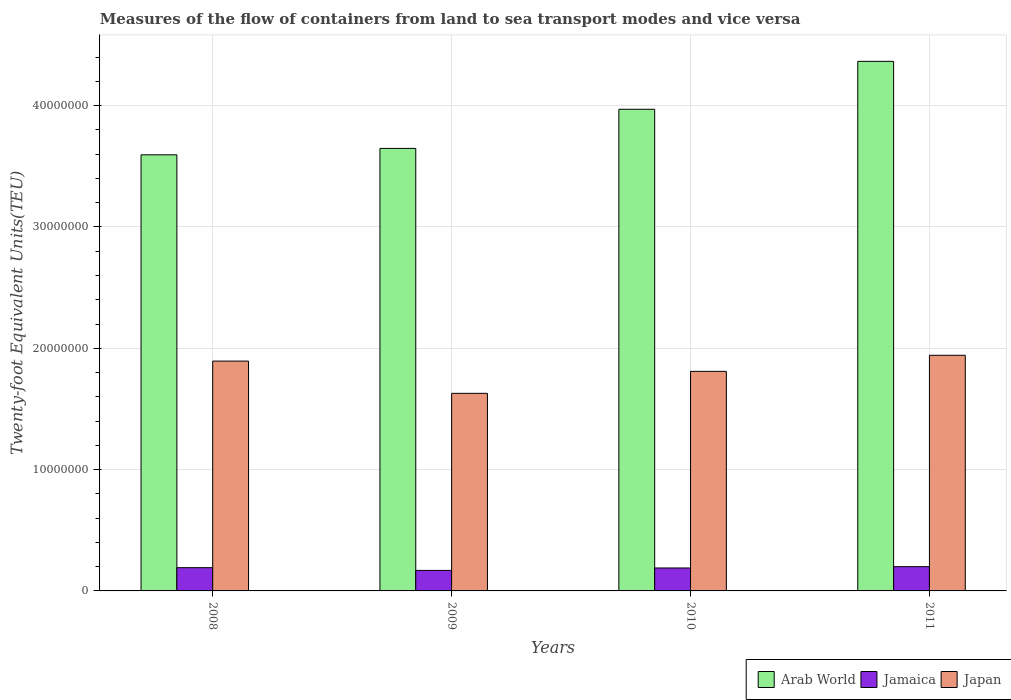How many different coloured bars are there?
Your answer should be compact. 3. How many groups of bars are there?
Ensure brevity in your answer.  4. Are the number of bars per tick equal to the number of legend labels?
Give a very brief answer. Yes. Are the number of bars on each tick of the X-axis equal?
Make the answer very short. Yes. How many bars are there on the 1st tick from the left?
Your answer should be compact. 3. How many bars are there on the 3rd tick from the right?
Ensure brevity in your answer.  3. What is the label of the 1st group of bars from the left?
Ensure brevity in your answer.  2008. What is the container port traffic in Jamaica in 2008?
Ensure brevity in your answer.  1.92e+06. Across all years, what is the maximum container port traffic in Japan?
Keep it short and to the point. 1.94e+07. Across all years, what is the minimum container port traffic in Japan?
Provide a short and direct response. 1.63e+07. In which year was the container port traffic in Japan minimum?
Your answer should be very brief. 2009. What is the total container port traffic in Jamaica in the graph?
Provide a short and direct response. 7.50e+06. What is the difference between the container port traffic in Japan in 2009 and that in 2010?
Keep it short and to the point. -1.81e+06. What is the difference between the container port traffic in Jamaica in 2008 and the container port traffic in Arab World in 2010?
Provide a short and direct response. -3.78e+07. What is the average container port traffic in Arab World per year?
Offer a terse response. 3.89e+07. In the year 2008, what is the difference between the container port traffic in Arab World and container port traffic in Japan?
Provide a succinct answer. 1.70e+07. What is the ratio of the container port traffic in Jamaica in 2008 to that in 2009?
Give a very brief answer. 1.13. Is the difference between the container port traffic in Arab World in 2009 and 2011 greater than the difference between the container port traffic in Japan in 2009 and 2011?
Offer a very short reply. No. What is the difference between the highest and the second highest container port traffic in Japan?
Give a very brief answer. 4.79e+05. What is the difference between the highest and the lowest container port traffic in Arab World?
Your response must be concise. 7.70e+06. Is the sum of the container port traffic in Japan in 2009 and 2011 greater than the maximum container port traffic in Jamaica across all years?
Give a very brief answer. Yes. What does the 2nd bar from the right in 2008 represents?
Provide a succinct answer. Jamaica. Is it the case that in every year, the sum of the container port traffic in Jamaica and container port traffic in Arab World is greater than the container port traffic in Japan?
Provide a short and direct response. Yes. How many bars are there?
Provide a short and direct response. 12. Are all the bars in the graph horizontal?
Give a very brief answer. No. What is the difference between two consecutive major ticks on the Y-axis?
Offer a very short reply. 1.00e+07. Are the values on the major ticks of Y-axis written in scientific E-notation?
Provide a short and direct response. No. Does the graph contain grids?
Keep it short and to the point. Yes. How many legend labels are there?
Provide a short and direct response. 3. What is the title of the graph?
Offer a terse response. Measures of the flow of containers from land to sea transport modes and vice versa. What is the label or title of the X-axis?
Offer a terse response. Years. What is the label or title of the Y-axis?
Provide a succinct answer. Twenty-foot Equivalent Units(TEU). What is the Twenty-foot Equivalent Units(TEU) of Arab World in 2008?
Your answer should be very brief. 3.59e+07. What is the Twenty-foot Equivalent Units(TEU) in Jamaica in 2008?
Your answer should be very brief. 1.92e+06. What is the Twenty-foot Equivalent Units(TEU) of Japan in 2008?
Keep it short and to the point. 1.89e+07. What is the Twenty-foot Equivalent Units(TEU) of Arab World in 2009?
Keep it short and to the point. 3.65e+07. What is the Twenty-foot Equivalent Units(TEU) in Jamaica in 2009?
Provide a succinct answer. 1.69e+06. What is the Twenty-foot Equivalent Units(TEU) of Japan in 2009?
Make the answer very short. 1.63e+07. What is the Twenty-foot Equivalent Units(TEU) in Arab World in 2010?
Your answer should be very brief. 3.97e+07. What is the Twenty-foot Equivalent Units(TEU) of Jamaica in 2010?
Make the answer very short. 1.89e+06. What is the Twenty-foot Equivalent Units(TEU) of Japan in 2010?
Give a very brief answer. 1.81e+07. What is the Twenty-foot Equivalent Units(TEU) of Arab World in 2011?
Your response must be concise. 4.36e+07. What is the Twenty-foot Equivalent Units(TEU) of Jamaica in 2011?
Provide a succinct answer. 2.00e+06. What is the Twenty-foot Equivalent Units(TEU) of Japan in 2011?
Provide a short and direct response. 1.94e+07. Across all years, what is the maximum Twenty-foot Equivalent Units(TEU) of Arab World?
Ensure brevity in your answer.  4.36e+07. Across all years, what is the maximum Twenty-foot Equivalent Units(TEU) in Jamaica?
Ensure brevity in your answer.  2.00e+06. Across all years, what is the maximum Twenty-foot Equivalent Units(TEU) of Japan?
Make the answer very short. 1.94e+07. Across all years, what is the minimum Twenty-foot Equivalent Units(TEU) of Arab World?
Offer a terse response. 3.59e+07. Across all years, what is the minimum Twenty-foot Equivalent Units(TEU) in Jamaica?
Offer a very short reply. 1.69e+06. Across all years, what is the minimum Twenty-foot Equivalent Units(TEU) in Japan?
Provide a succinct answer. 1.63e+07. What is the total Twenty-foot Equivalent Units(TEU) in Arab World in the graph?
Your response must be concise. 1.56e+08. What is the total Twenty-foot Equivalent Units(TEU) of Jamaica in the graph?
Provide a succinct answer. 7.50e+06. What is the total Twenty-foot Equivalent Units(TEU) in Japan in the graph?
Offer a very short reply. 7.28e+07. What is the difference between the Twenty-foot Equivalent Units(TEU) of Arab World in 2008 and that in 2009?
Your answer should be compact. -5.29e+05. What is the difference between the Twenty-foot Equivalent Units(TEU) of Jamaica in 2008 and that in 2009?
Provide a succinct answer. 2.26e+05. What is the difference between the Twenty-foot Equivalent Units(TEU) of Japan in 2008 and that in 2009?
Offer a terse response. 2.66e+06. What is the difference between the Twenty-foot Equivalent Units(TEU) in Arab World in 2008 and that in 2010?
Provide a succinct answer. -3.75e+06. What is the difference between the Twenty-foot Equivalent Units(TEU) of Jamaica in 2008 and that in 2010?
Your answer should be very brief. 2.42e+04. What is the difference between the Twenty-foot Equivalent Units(TEU) of Japan in 2008 and that in 2010?
Ensure brevity in your answer.  8.45e+05. What is the difference between the Twenty-foot Equivalent Units(TEU) of Arab World in 2008 and that in 2011?
Ensure brevity in your answer.  -7.70e+06. What is the difference between the Twenty-foot Equivalent Units(TEU) of Jamaica in 2008 and that in 2011?
Your answer should be compact. -8.37e+04. What is the difference between the Twenty-foot Equivalent Units(TEU) of Japan in 2008 and that in 2011?
Offer a very short reply. -4.79e+05. What is the difference between the Twenty-foot Equivalent Units(TEU) in Arab World in 2009 and that in 2010?
Offer a terse response. -3.22e+06. What is the difference between the Twenty-foot Equivalent Units(TEU) of Jamaica in 2009 and that in 2010?
Your answer should be very brief. -2.02e+05. What is the difference between the Twenty-foot Equivalent Units(TEU) in Japan in 2009 and that in 2010?
Make the answer very short. -1.81e+06. What is the difference between the Twenty-foot Equivalent Units(TEU) of Arab World in 2009 and that in 2011?
Provide a succinct answer. -7.17e+06. What is the difference between the Twenty-foot Equivalent Units(TEU) of Jamaica in 2009 and that in 2011?
Provide a short and direct response. -3.10e+05. What is the difference between the Twenty-foot Equivalent Units(TEU) in Japan in 2009 and that in 2011?
Offer a terse response. -3.14e+06. What is the difference between the Twenty-foot Equivalent Units(TEU) in Arab World in 2010 and that in 2011?
Your answer should be compact. -3.95e+06. What is the difference between the Twenty-foot Equivalent Units(TEU) in Jamaica in 2010 and that in 2011?
Keep it short and to the point. -1.08e+05. What is the difference between the Twenty-foot Equivalent Units(TEU) in Japan in 2010 and that in 2011?
Provide a short and direct response. -1.32e+06. What is the difference between the Twenty-foot Equivalent Units(TEU) of Arab World in 2008 and the Twenty-foot Equivalent Units(TEU) of Jamaica in 2009?
Your response must be concise. 3.43e+07. What is the difference between the Twenty-foot Equivalent Units(TEU) of Arab World in 2008 and the Twenty-foot Equivalent Units(TEU) of Japan in 2009?
Keep it short and to the point. 1.97e+07. What is the difference between the Twenty-foot Equivalent Units(TEU) in Jamaica in 2008 and the Twenty-foot Equivalent Units(TEU) in Japan in 2009?
Your answer should be compact. -1.44e+07. What is the difference between the Twenty-foot Equivalent Units(TEU) of Arab World in 2008 and the Twenty-foot Equivalent Units(TEU) of Jamaica in 2010?
Your answer should be very brief. 3.41e+07. What is the difference between the Twenty-foot Equivalent Units(TEU) in Arab World in 2008 and the Twenty-foot Equivalent Units(TEU) in Japan in 2010?
Your response must be concise. 1.78e+07. What is the difference between the Twenty-foot Equivalent Units(TEU) in Jamaica in 2008 and the Twenty-foot Equivalent Units(TEU) in Japan in 2010?
Offer a terse response. -1.62e+07. What is the difference between the Twenty-foot Equivalent Units(TEU) in Arab World in 2008 and the Twenty-foot Equivalent Units(TEU) in Jamaica in 2011?
Give a very brief answer. 3.39e+07. What is the difference between the Twenty-foot Equivalent Units(TEU) in Arab World in 2008 and the Twenty-foot Equivalent Units(TEU) in Japan in 2011?
Provide a short and direct response. 1.65e+07. What is the difference between the Twenty-foot Equivalent Units(TEU) in Jamaica in 2008 and the Twenty-foot Equivalent Units(TEU) in Japan in 2011?
Offer a very short reply. -1.75e+07. What is the difference between the Twenty-foot Equivalent Units(TEU) of Arab World in 2009 and the Twenty-foot Equivalent Units(TEU) of Jamaica in 2010?
Make the answer very short. 3.46e+07. What is the difference between the Twenty-foot Equivalent Units(TEU) in Arab World in 2009 and the Twenty-foot Equivalent Units(TEU) in Japan in 2010?
Provide a succinct answer. 1.84e+07. What is the difference between the Twenty-foot Equivalent Units(TEU) of Jamaica in 2009 and the Twenty-foot Equivalent Units(TEU) of Japan in 2010?
Provide a short and direct response. -1.64e+07. What is the difference between the Twenty-foot Equivalent Units(TEU) of Arab World in 2009 and the Twenty-foot Equivalent Units(TEU) of Jamaica in 2011?
Offer a very short reply. 3.45e+07. What is the difference between the Twenty-foot Equivalent Units(TEU) in Arab World in 2009 and the Twenty-foot Equivalent Units(TEU) in Japan in 2011?
Provide a short and direct response. 1.71e+07. What is the difference between the Twenty-foot Equivalent Units(TEU) of Jamaica in 2009 and the Twenty-foot Equivalent Units(TEU) of Japan in 2011?
Your response must be concise. -1.77e+07. What is the difference between the Twenty-foot Equivalent Units(TEU) of Arab World in 2010 and the Twenty-foot Equivalent Units(TEU) of Jamaica in 2011?
Keep it short and to the point. 3.77e+07. What is the difference between the Twenty-foot Equivalent Units(TEU) of Arab World in 2010 and the Twenty-foot Equivalent Units(TEU) of Japan in 2011?
Your response must be concise. 2.03e+07. What is the difference between the Twenty-foot Equivalent Units(TEU) of Jamaica in 2010 and the Twenty-foot Equivalent Units(TEU) of Japan in 2011?
Ensure brevity in your answer.  -1.75e+07. What is the average Twenty-foot Equivalent Units(TEU) in Arab World per year?
Provide a short and direct response. 3.89e+07. What is the average Twenty-foot Equivalent Units(TEU) in Jamaica per year?
Your answer should be very brief. 1.87e+06. What is the average Twenty-foot Equivalent Units(TEU) in Japan per year?
Provide a succinct answer. 1.82e+07. In the year 2008, what is the difference between the Twenty-foot Equivalent Units(TEU) of Arab World and Twenty-foot Equivalent Units(TEU) of Jamaica?
Provide a short and direct response. 3.40e+07. In the year 2008, what is the difference between the Twenty-foot Equivalent Units(TEU) of Arab World and Twenty-foot Equivalent Units(TEU) of Japan?
Your response must be concise. 1.70e+07. In the year 2008, what is the difference between the Twenty-foot Equivalent Units(TEU) of Jamaica and Twenty-foot Equivalent Units(TEU) of Japan?
Give a very brief answer. -1.70e+07. In the year 2009, what is the difference between the Twenty-foot Equivalent Units(TEU) in Arab World and Twenty-foot Equivalent Units(TEU) in Jamaica?
Make the answer very short. 3.48e+07. In the year 2009, what is the difference between the Twenty-foot Equivalent Units(TEU) in Arab World and Twenty-foot Equivalent Units(TEU) in Japan?
Keep it short and to the point. 2.02e+07. In the year 2009, what is the difference between the Twenty-foot Equivalent Units(TEU) in Jamaica and Twenty-foot Equivalent Units(TEU) in Japan?
Give a very brief answer. -1.46e+07. In the year 2010, what is the difference between the Twenty-foot Equivalent Units(TEU) in Arab World and Twenty-foot Equivalent Units(TEU) in Jamaica?
Your response must be concise. 3.78e+07. In the year 2010, what is the difference between the Twenty-foot Equivalent Units(TEU) in Arab World and Twenty-foot Equivalent Units(TEU) in Japan?
Offer a very short reply. 2.16e+07. In the year 2010, what is the difference between the Twenty-foot Equivalent Units(TEU) in Jamaica and Twenty-foot Equivalent Units(TEU) in Japan?
Make the answer very short. -1.62e+07. In the year 2011, what is the difference between the Twenty-foot Equivalent Units(TEU) in Arab World and Twenty-foot Equivalent Units(TEU) in Jamaica?
Offer a very short reply. 4.16e+07. In the year 2011, what is the difference between the Twenty-foot Equivalent Units(TEU) in Arab World and Twenty-foot Equivalent Units(TEU) in Japan?
Offer a terse response. 2.42e+07. In the year 2011, what is the difference between the Twenty-foot Equivalent Units(TEU) of Jamaica and Twenty-foot Equivalent Units(TEU) of Japan?
Give a very brief answer. -1.74e+07. What is the ratio of the Twenty-foot Equivalent Units(TEU) of Arab World in 2008 to that in 2009?
Ensure brevity in your answer.  0.99. What is the ratio of the Twenty-foot Equivalent Units(TEU) in Jamaica in 2008 to that in 2009?
Keep it short and to the point. 1.13. What is the ratio of the Twenty-foot Equivalent Units(TEU) of Japan in 2008 to that in 2009?
Provide a short and direct response. 1.16. What is the ratio of the Twenty-foot Equivalent Units(TEU) in Arab World in 2008 to that in 2010?
Give a very brief answer. 0.91. What is the ratio of the Twenty-foot Equivalent Units(TEU) of Jamaica in 2008 to that in 2010?
Provide a short and direct response. 1.01. What is the ratio of the Twenty-foot Equivalent Units(TEU) of Japan in 2008 to that in 2010?
Provide a short and direct response. 1.05. What is the ratio of the Twenty-foot Equivalent Units(TEU) in Arab World in 2008 to that in 2011?
Your answer should be compact. 0.82. What is the ratio of the Twenty-foot Equivalent Units(TEU) in Jamaica in 2008 to that in 2011?
Provide a short and direct response. 0.96. What is the ratio of the Twenty-foot Equivalent Units(TEU) of Japan in 2008 to that in 2011?
Ensure brevity in your answer.  0.98. What is the ratio of the Twenty-foot Equivalent Units(TEU) in Arab World in 2009 to that in 2010?
Provide a succinct answer. 0.92. What is the ratio of the Twenty-foot Equivalent Units(TEU) of Jamaica in 2009 to that in 2010?
Make the answer very short. 0.89. What is the ratio of the Twenty-foot Equivalent Units(TEU) of Japan in 2009 to that in 2010?
Provide a short and direct response. 0.9. What is the ratio of the Twenty-foot Equivalent Units(TEU) in Arab World in 2009 to that in 2011?
Your response must be concise. 0.84. What is the ratio of the Twenty-foot Equivalent Units(TEU) of Jamaica in 2009 to that in 2011?
Ensure brevity in your answer.  0.84. What is the ratio of the Twenty-foot Equivalent Units(TEU) of Japan in 2009 to that in 2011?
Keep it short and to the point. 0.84. What is the ratio of the Twenty-foot Equivalent Units(TEU) in Arab World in 2010 to that in 2011?
Your answer should be compact. 0.91. What is the ratio of the Twenty-foot Equivalent Units(TEU) of Jamaica in 2010 to that in 2011?
Provide a short and direct response. 0.95. What is the ratio of the Twenty-foot Equivalent Units(TEU) in Japan in 2010 to that in 2011?
Provide a succinct answer. 0.93. What is the difference between the highest and the second highest Twenty-foot Equivalent Units(TEU) in Arab World?
Keep it short and to the point. 3.95e+06. What is the difference between the highest and the second highest Twenty-foot Equivalent Units(TEU) of Jamaica?
Offer a very short reply. 8.37e+04. What is the difference between the highest and the second highest Twenty-foot Equivalent Units(TEU) of Japan?
Your answer should be compact. 4.79e+05. What is the difference between the highest and the lowest Twenty-foot Equivalent Units(TEU) in Arab World?
Provide a succinct answer. 7.70e+06. What is the difference between the highest and the lowest Twenty-foot Equivalent Units(TEU) of Jamaica?
Provide a succinct answer. 3.10e+05. What is the difference between the highest and the lowest Twenty-foot Equivalent Units(TEU) in Japan?
Your response must be concise. 3.14e+06. 